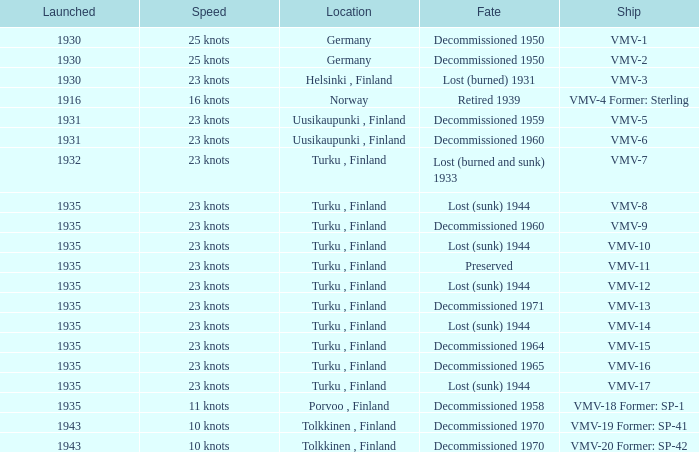What is the average launch date of the vmv-1 vessel in Germany? 1930.0. 